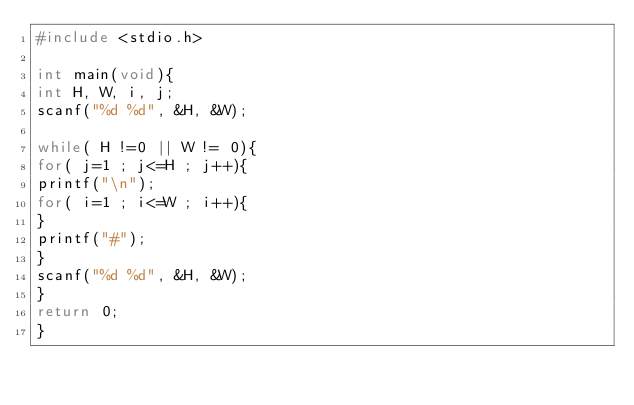Convert code to text. <code><loc_0><loc_0><loc_500><loc_500><_C_>#include <stdio.h>

int main(void){
int H, W, i, j;
scanf("%d %d", &H, &W);

while( H !=0 || W != 0){
for( j=1 ; j<=H ; j++){
printf("\n");
for( i=1 ; i<=W ; i++){
}
printf("#");
}
scanf("%d %d", &H, &W);
}
return 0;
}</code> 